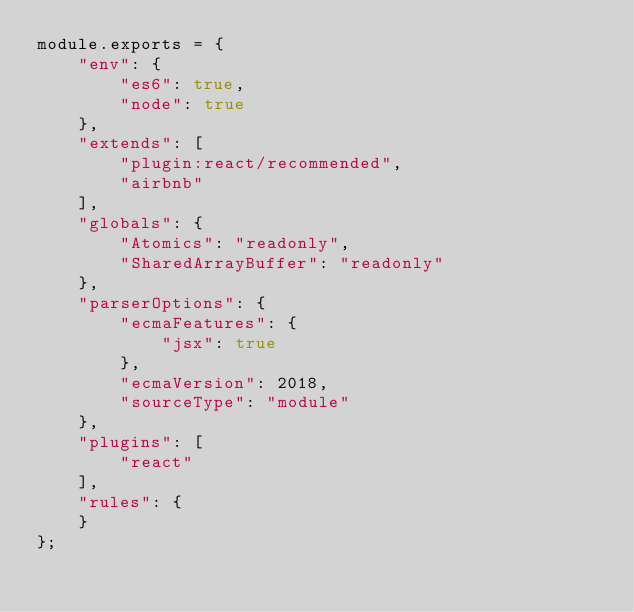Convert code to text. <code><loc_0><loc_0><loc_500><loc_500><_JavaScript_>module.exports = {
    "env": {
        "es6": true,
        "node": true
    },
    "extends": [
        "plugin:react/recommended",
        "airbnb"
    ],
    "globals": {
        "Atomics": "readonly",
        "SharedArrayBuffer": "readonly"
    },
    "parserOptions": {
        "ecmaFeatures": {
            "jsx": true
        },
        "ecmaVersion": 2018,
        "sourceType": "module"
    },
    "plugins": [
        "react"
    ],
    "rules": {
    }
};</code> 